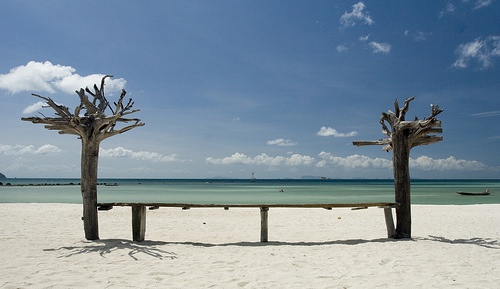Describe the objects in this image and their specific colors. I can see bench in gray, black, and ivory tones, boat in gray and black tones, and people in gray, darkgreen, and brown tones in this image. 